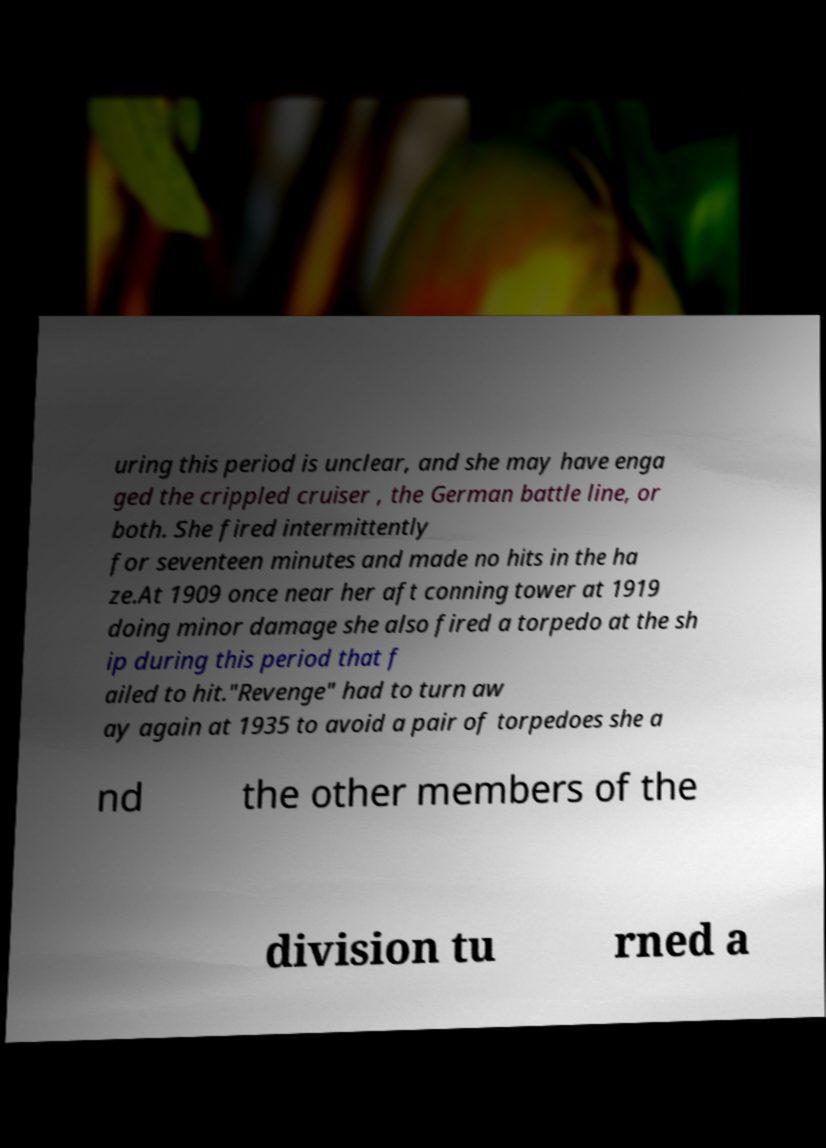I need the written content from this picture converted into text. Can you do that? uring this period is unclear, and she may have enga ged the crippled cruiser , the German battle line, or both. She fired intermittently for seventeen minutes and made no hits in the ha ze.At 1909 once near her aft conning tower at 1919 doing minor damage she also fired a torpedo at the sh ip during this period that f ailed to hit."Revenge" had to turn aw ay again at 1935 to avoid a pair of torpedoes she a nd the other members of the division tu rned a 